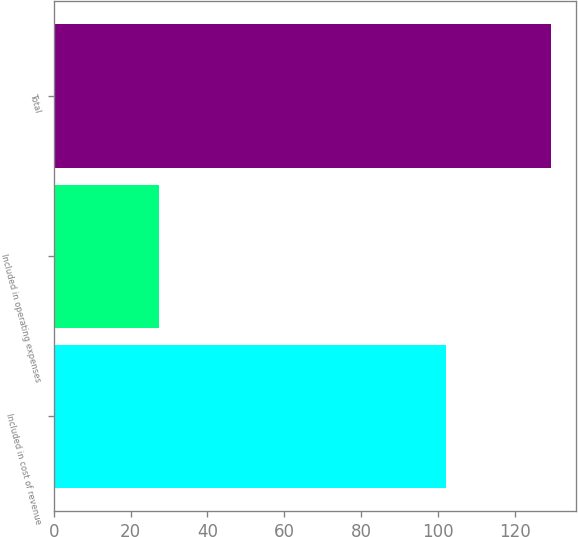Convert chart. <chart><loc_0><loc_0><loc_500><loc_500><bar_chart><fcel>Included in cost of revenue<fcel>Included in operating expenses<fcel>Total<nl><fcel>102.1<fcel>27.5<fcel>129.6<nl></chart> 